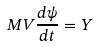<formula> <loc_0><loc_0><loc_500><loc_500>M V \frac { d \psi } { d t } = Y</formula> 